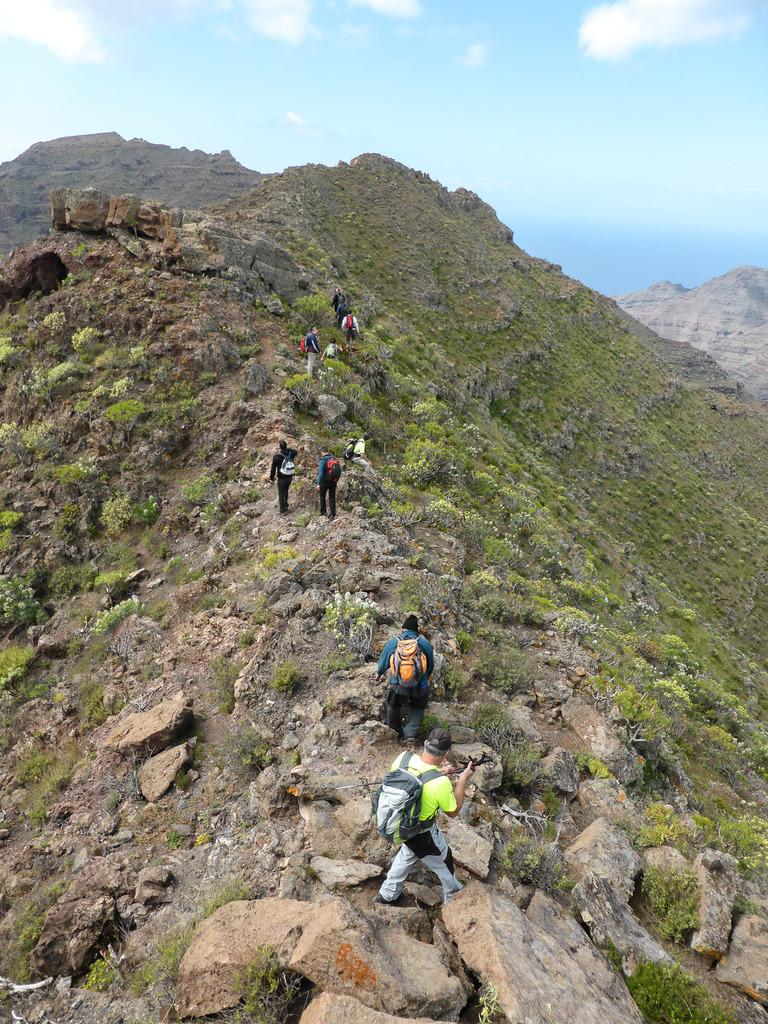Who or what is present in the image? There are people in the image. What are the people doing in the image? The people are walking on a hill. What can be seen in the sky in the background of the image? There are clouds visible in the sky in the background of the image. What type of copper material can be seen on the hill in the image? There is no copper material present in the image; it features people walking on a hill with clouds in the sky. 